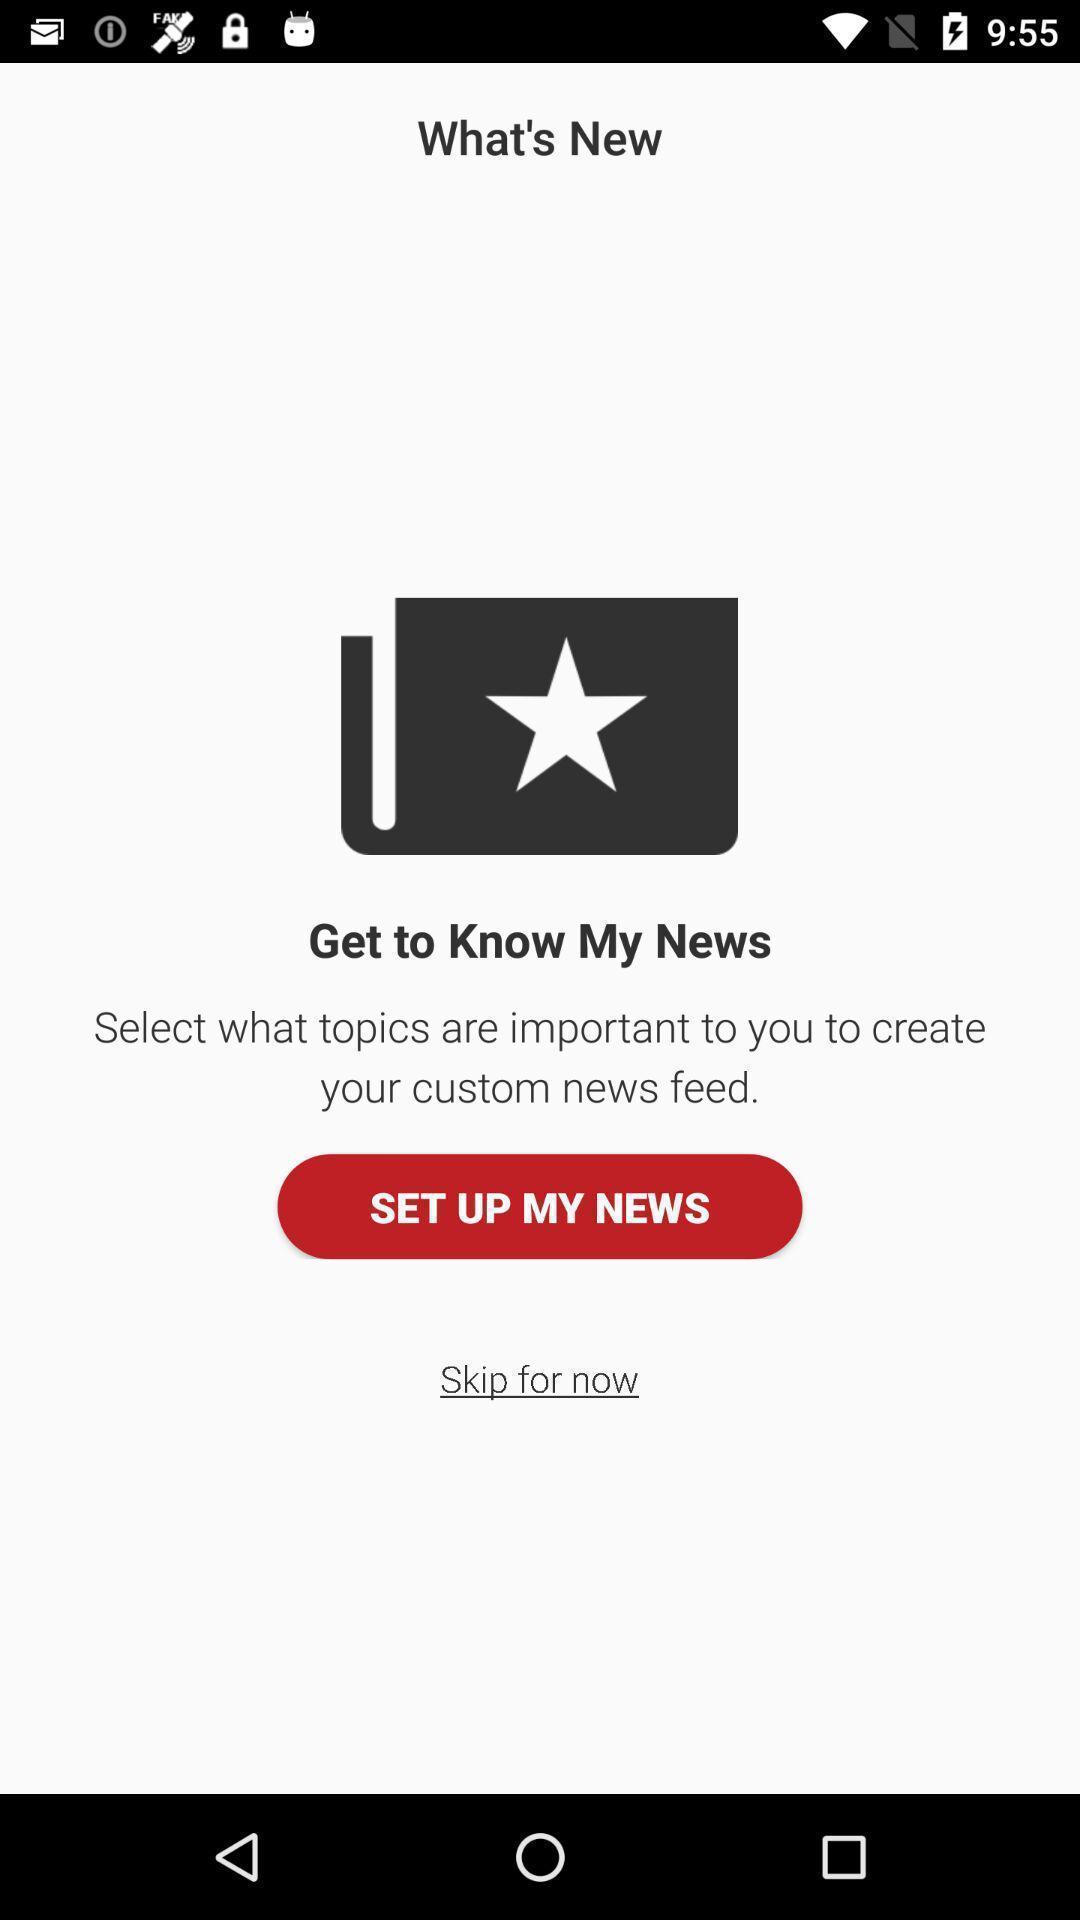Give me a summary of this screen capture. Welcome page displayed to set up news in news application. 